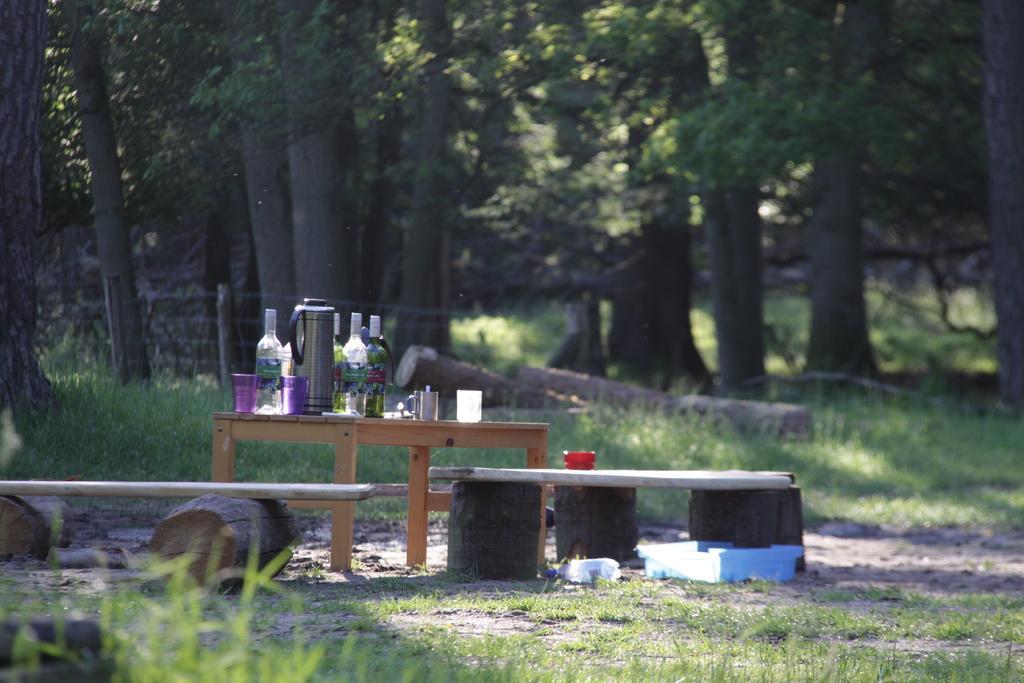Please provide a concise description of this image. There is a table. On the table there is a jug, bottles, glasses and few other items. Near to that there are benches. On the ground there is grass. Near to the bench there is a box. In the background there are trees. Also there is a railing with poles. On the ground there are wooden logs. 